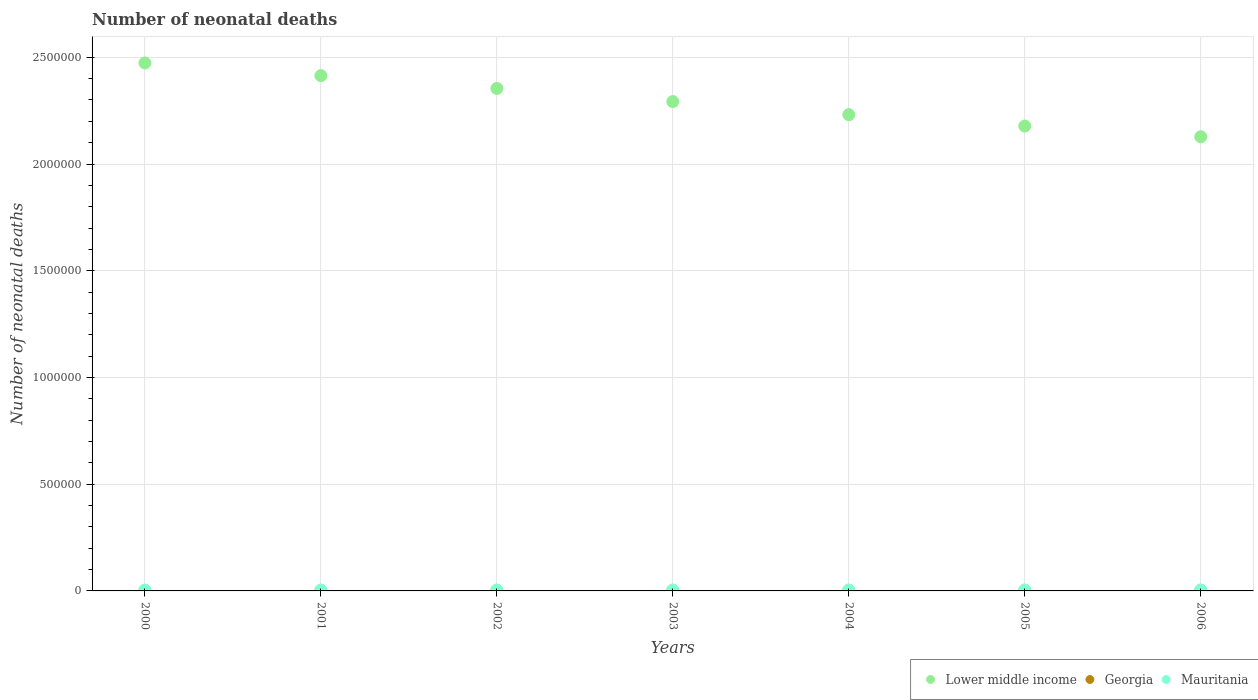Is the number of dotlines equal to the number of legend labels?
Your answer should be very brief. Yes. What is the number of neonatal deaths in in Lower middle income in 2003?
Keep it short and to the point. 2.29e+06. Across all years, what is the maximum number of neonatal deaths in in Mauritania?
Offer a very short reply. 4834. Across all years, what is the minimum number of neonatal deaths in in Lower middle income?
Provide a succinct answer. 2.13e+06. In which year was the number of neonatal deaths in in Lower middle income maximum?
Keep it short and to the point. 2000. In which year was the number of neonatal deaths in in Georgia minimum?
Offer a very short reply. 2006. What is the total number of neonatal deaths in in Mauritania in the graph?
Make the answer very short. 3.22e+04. What is the difference between the number of neonatal deaths in in Georgia in 2003 and that in 2006?
Your answer should be compact. 116. What is the difference between the number of neonatal deaths in in Georgia in 2006 and the number of neonatal deaths in in Mauritania in 2000?
Your answer should be compact. -3532. What is the average number of neonatal deaths in in Lower middle income per year?
Provide a succinct answer. 2.30e+06. In the year 2006, what is the difference between the number of neonatal deaths in in Mauritania and number of neonatal deaths in in Lower middle income?
Your answer should be compact. -2.12e+06. What is the ratio of the number of neonatal deaths in in Georgia in 2001 to that in 2005?
Your answer should be compact. 1.18. Is the difference between the number of neonatal deaths in in Mauritania in 2001 and 2002 greater than the difference between the number of neonatal deaths in in Lower middle income in 2001 and 2002?
Your response must be concise. No. What is the difference between the highest and the second highest number of neonatal deaths in in Lower middle income?
Offer a very short reply. 5.94e+04. What is the difference between the highest and the lowest number of neonatal deaths in in Georgia?
Provide a succinct answer. 260. In how many years, is the number of neonatal deaths in in Lower middle income greater than the average number of neonatal deaths in in Lower middle income taken over all years?
Offer a terse response. 3. Is the sum of the number of neonatal deaths in in Lower middle income in 2004 and 2005 greater than the maximum number of neonatal deaths in in Mauritania across all years?
Give a very brief answer. Yes. Is the number of neonatal deaths in in Mauritania strictly greater than the number of neonatal deaths in in Georgia over the years?
Your response must be concise. Yes. What is the difference between two consecutive major ticks on the Y-axis?
Make the answer very short. 5.00e+05. Are the values on the major ticks of Y-axis written in scientific E-notation?
Provide a succinct answer. No. Does the graph contain any zero values?
Keep it short and to the point. No. Where does the legend appear in the graph?
Keep it short and to the point. Bottom right. What is the title of the graph?
Make the answer very short. Number of neonatal deaths. Does "Iraq" appear as one of the legend labels in the graph?
Give a very brief answer. No. What is the label or title of the Y-axis?
Provide a succinct answer. Number of neonatal deaths. What is the Number of neonatal deaths in Lower middle income in 2000?
Make the answer very short. 2.47e+06. What is the Number of neonatal deaths of Georgia in 2000?
Offer a terse response. 1074. What is the Number of neonatal deaths in Mauritania in 2000?
Keep it short and to the point. 4346. What is the Number of neonatal deaths in Lower middle income in 2001?
Keep it short and to the point. 2.41e+06. What is the Number of neonatal deaths of Georgia in 2001?
Keep it short and to the point. 1014. What is the Number of neonatal deaths of Mauritania in 2001?
Make the answer very short. 4421. What is the Number of neonatal deaths in Lower middle income in 2002?
Provide a short and direct response. 2.35e+06. What is the Number of neonatal deaths in Georgia in 2002?
Offer a very short reply. 965. What is the Number of neonatal deaths in Mauritania in 2002?
Offer a very short reply. 4520. What is the Number of neonatal deaths of Lower middle income in 2003?
Provide a succinct answer. 2.29e+06. What is the Number of neonatal deaths in Georgia in 2003?
Provide a succinct answer. 930. What is the Number of neonatal deaths of Mauritania in 2003?
Your response must be concise. 4619. What is the Number of neonatal deaths in Lower middle income in 2004?
Provide a succinct answer. 2.23e+06. What is the Number of neonatal deaths of Georgia in 2004?
Your answer should be compact. 897. What is the Number of neonatal deaths in Mauritania in 2004?
Give a very brief answer. 4712. What is the Number of neonatal deaths in Lower middle income in 2005?
Your answer should be compact. 2.18e+06. What is the Number of neonatal deaths of Georgia in 2005?
Give a very brief answer. 856. What is the Number of neonatal deaths of Mauritania in 2005?
Your response must be concise. 4773. What is the Number of neonatal deaths of Lower middle income in 2006?
Ensure brevity in your answer.  2.13e+06. What is the Number of neonatal deaths in Georgia in 2006?
Keep it short and to the point. 814. What is the Number of neonatal deaths in Mauritania in 2006?
Make the answer very short. 4834. Across all years, what is the maximum Number of neonatal deaths of Lower middle income?
Give a very brief answer. 2.47e+06. Across all years, what is the maximum Number of neonatal deaths of Georgia?
Offer a terse response. 1074. Across all years, what is the maximum Number of neonatal deaths in Mauritania?
Provide a short and direct response. 4834. Across all years, what is the minimum Number of neonatal deaths in Lower middle income?
Offer a very short reply. 2.13e+06. Across all years, what is the minimum Number of neonatal deaths of Georgia?
Provide a short and direct response. 814. Across all years, what is the minimum Number of neonatal deaths of Mauritania?
Give a very brief answer. 4346. What is the total Number of neonatal deaths in Lower middle income in the graph?
Your answer should be compact. 1.61e+07. What is the total Number of neonatal deaths in Georgia in the graph?
Your answer should be compact. 6550. What is the total Number of neonatal deaths of Mauritania in the graph?
Your answer should be compact. 3.22e+04. What is the difference between the Number of neonatal deaths of Lower middle income in 2000 and that in 2001?
Provide a short and direct response. 5.94e+04. What is the difference between the Number of neonatal deaths of Georgia in 2000 and that in 2001?
Give a very brief answer. 60. What is the difference between the Number of neonatal deaths of Mauritania in 2000 and that in 2001?
Provide a succinct answer. -75. What is the difference between the Number of neonatal deaths in Lower middle income in 2000 and that in 2002?
Your answer should be compact. 1.19e+05. What is the difference between the Number of neonatal deaths in Georgia in 2000 and that in 2002?
Offer a terse response. 109. What is the difference between the Number of neonatal deaths of Mauritania in 2000 and that in 2002?
Offer a terse response. -174. What is the difference between the Number of neonatal deaths in Lower middle income in 2000 and that in 2003?
Offer a terse response. 1.81e+05. What is the difference between the Number of neonatal deaths in Georgia in 2000 and that in 2003?
Your answer should be compact. 144. What is the difference between the Number of neonatal deaths in Mauritania in 2000 and that in 2003?
Offer a terse response. -273. What is the difference between the Number of neonatal deaths in Lower middle income in 2000 and that in 2004?
Provide a short and direct response. 2.42e+05. What is the difference between the Number of neonatal deaths of Georgia in 2000 and that in 2004?
Make the answer very short. 177. What is the difference between the Number of neonatal deaths in Mauritania in 2000 and that in 2004?
Offer a terse response. -366. What is the difference between the Number of neonatal deaths of Lower middle income in 2000 and that in 2005?
Give a very brief answer. 2.96e+05. What is the difference between the Number of neonatal deaths in Georgia in 2000 and that in 2005?
Your answer should be very brief. 218. What is the difference between the Number of neonatal deaths in Mauritania in 2000 and that in 2005?
Keep it short and to the point. -427. What is the difference between the Number of neonatal deaths in Lower middle income in 2000 and that in 2006?
Offer a very short reply. 3.46e+05. What is the difference between the Number of neonatal deaths of Georgia in 2000 and that in 2006?
Ensure brevity in your answer.  260. What is the difference between the Number of neonatal deaths in Mauritania in 2000 and that in 2006?
Provide a succinct answer. -488. What is the difference between the Number of neonatal deaths in Lower middle income in 2001 and that in 2002?
Offer a terse response. 6.00e+04. What is the difference between the Number of neonatal deaths in Mauritania in 2001 and that in 2002?
Offer a very short reply. -99. What is the difference between the Number of neonatal deaths in Lower middle income in 2001 and that in 2003?
Provide a short and direct response. 1.22e+05. What is the difference between the Number of neonatal deaths in Mauritania in 2001 and that in 2003?
Ensure brevity in your answer.  -198. What is the difference between the Number of neonatal deaths of Lower middle income in 2001 and that in 2004?
Give a very brief answer. 1.83e+05. What is the difference between the Number of neonatal deaths of Georgia in 2001 and that in 2004?
Make the answer very short. 117. What is the difference between the Number of neonatal deaths of Mauritania in 2001 and that in 2004?
Your answer should be very brief. -291. What is the difference between the Number of neonatal deaths in Lower middle income in 2001 and that in 2005?
Your response must be concise. 2.36e+05. What is the difference between the Number of neonatal deaths in Georgia in 2001 and that in 2005?
Your answer should be very brief. 158. What is the difference between the Number of neonatal deaths of Mauritania in 2001 and that in 2005?
Your response must be concise. -352. What is the difference between the Number of neonatal deaths in Lower middle income in 2001 and that in 2006?
Ensure brevity in your answer.  2.86e+05. What is the difference between the Number of neonatal deaths in Mauritania in 2001 and that in 2006?
Your answer should be very brief. -413. What is the difference between the Number of neonatal deaths of Lower middle income in 2002 and that in 2003?
Provide a succinct answer. 6.15e+04. What is the difference between the Number of neonatal deaths in Georgia in 2002 and that in 2003?
Your answer should be very brief. 35. What is the difference between the Number of neonatal deaths of Mauritania in 2002 and that in 2003?
Your answer should be compact. -99. What is the difference between the Number of neonatal deaths of Lower middle income in 2002 and that in 2004?
Offer a terse response. 1.23e+05. What is the difference between the Number of neonatal deaths in Georgia in 2002 and that in 2004?
Ensure brevity in your answer.  68. What is the difference between the Number of neonatal deaths of Mauritania in 2002 and that in 2004?
Your answer should be very brief. -192. What is the difference between the Number of neonatal deaths of Lower middle income in 2002 and that in 2005?
Offer a terse response. 1.76e+05. What is the difference between the Number of neonatal deaths in Georgia in 2002 and that in 2005?
Ensure brevity in your answer.  109. What is the difference between the Number of neonatal deaths of Mauritania in 2002 and that in 2005?
Provide a short and direct response. -253. What is the difference between the Number of neonatal deaths of Lower middle income in 2002 and that in 2006?
Make the answer very short. 2.26e+05. What is the difference between the Number of neonatal deaths in Georgia in 2002 and that in 2006?
Offer a very short reply. 151. What is the difference between the Number of neonatal deaths in Mauritania in 2002 and that in 2006?
Make the answer very short. -314. What is the difference between the Number of neonatal deaths in Lower middle income in 2003 and that in 2004?
Keep it short and to the point. 6.13e+04. What is the difference between the Number of neonatal deaths in Mauritania in 2003 and that in 2004?
Your answer should be compact. -93. What is the difference between the Number of neonatal deaths in Lower middle income in 2003 and that in 2005?
Offer a terse response. 1.15e+05. What is the difference between the Number of neonatal deaths of Georgia in 2003 and that in 2005?
Your answer should be very brief. 74. What is the difference between the Number of neonatal deaths of Mauritania in 2003 and that in 2005?
Provide a short and direct response. -154. What is the difference between the Number of neonatal deaths of Lower middle income in 2003 and that in 2006?
Your answer should be compact. 1.65e+05. What is the difference between the Number of neonatal deaths of Georgia in 2003 and that in 2006?
Make the answer very short. 116. What is the difference between the Number of neonatal deaths in Mauritania in 2003 and that in 2006?
Your response must be concise. -215. What is the difference between the Number of neonatal deaths of Lower middle income in 2004 and that in 2005?
Your answer should be very brief. 5.34e+04. What is the difference between the Number of neonatal deaths in Mauritania in 2004 and that in 2005?
Your answer should be compact. -61. What is the difference between the Number of neonatal deaths in Lower middle income in 2004 and that in 2006?
Your answer should be compact. 1.04e+05. What is the difference between the Number of neonatal deaths in Georgia in 2004 and that in 2006?
Give a very brief answer. 83. What is the difference between the Number of neonatal deaths of Mauritania in 2004 and that in 2006?
Offer a terse response. -122. What is the difference between the Number of neonatal deaths of Lower middle income in 2005 and that in 2006?
Ensure brevity in your answer.  5.02e+04. What is the difference between the Number of neonatal deaths of Mauritania in 2005 and that in 2006?
Ensure brevity in your answer.  -61. What is the difference between the Number of neonatal deaths in Lower middle income in 2000 and the Number of neonatal deaths in Georgia in 2001?
Offer a very short reply. 2.47e+06. What is the difference between the Number of neonatal deaths in Lower middle income in 2000 and the Number of neonatal deaths in Mauritania in 2001?
Your answer should be compact. 2.47e+06. What is the difference between the Number of neonatal deaths in Georgia in 2000 and the Number of neonatal deaths in Mauritania in 2001?
Make the answer very short. -3347. What is the difference between the Number of neonatal deaths in Lower middle income in 2000 and the Number of neonatal deaths in Georgia in 2002?
Your answer should be compact. 2.47e+06. What is the difference between the Number of neonatal deaths of Lower middle income in 2000 and the Number of neonatal deaths of Mauritania in 2002?
Give a very brief answer. 2.47e+06. What is the difference between the Number of neonatal deaths in Georgia in 2000 and the Number of neonatal deaths in Mauritania in 2002?
Keep it short and to the point. -3446. What is the difference between the Number of neonatal deaths of Lower middle income in 2000 and the Number of neonatal deaths of Georgia in 2003?
Your answer should be compact. 2.47e+06. What is the difference between the Number of neonatal deaths of Lower middle income in 2000 and the Number of neonatal deaths of Mauritania in 2003?
Ensure brevity in your answer.  2.47e+06. What is the difference between the Number of neonatal deaths in Georgia in 2000 and the Number of neonatal deaths in Mauritania in 2003?
Your response must be concise. -3545. What is the difference between the Number of neonatal deaths of Lower middle income in 2000 and the Number of neonatal deaths of Georgia in 2004?
Your answer should be compact. 2.47e+06. What is the difference between the Number of neonatal deaths in Lower middle income in 2000 and the Number of neonatal deaths in Mauritania in 2004?
Your answer should be compact. 2.47e+06. What is the difference between the Number of neonatal deaths of Georgia in 2000 and the Number of neonatal deaths of Mauritania in 2004?
Your answer should be compact. -3638. What is the difference between the Number of neonatal deaths in Lower middle income in 2000 and the Number of neonatal deaths in Georgia in 2005?
Ensure brevity in your answer.  2.47e+06. What is the difference between the Number of neonatal deaths of Lower middle income in 2000 and the Number of neonatal deaths of Mauritania in 2005?
Your answer should be very brief. 2.47e+06. What is the difference between the Number of neonatal deaths of Georgia in 2000 and the Number of neonatal deaths of Mauritania in 2005?
Ensure brevity in your answer.  -3699. What is the difference between the Number of neonatal deaths in Lower middle income in 2000 and the Number of neonatal deaths in Georgia in 2006?
Your answer should be compact. 2.47e+06. What is the difference between the Number of neonatal deaths in Lower middle income in 2000 and the Number of neonatal deaths in Mauritania in 2006?
Your answer should be compact. 2.47e+06. What is the difference between the Number of neonatal deaths in Georgia in 2000 and the Number of neonatal deaths in Mauritania in 2006?
Your response must be concise. -3760. What is the difference between the Number of neonatal deaths of Lower middle income in 2001 and the Number of neonatal deaths of Georgia in 2002?
Your answer should be compact. 2.41e+06. What is the difference between the Number of neonatal deaths in Lower middle income in 2001 and the Number of neonatal deaths in Mauritania in 2002?
Your response must be concise. 2.41e+06. What is the difference between the Number of neonatal deaths of Georgia in 2001 and the Number of neonatal deaths of Mauritania in 2002?
Your answer should be compact. -3506. What is the difference between the Number of neonatal deaths in Lower middle income in 2001 and the Number of neonatal deaths in Georgia in 2003?
Offer a terse response. 2.41e+06. What is the difference between the Number of neonatal deaths in Lower middle income in 2001 and the Number of neonatal deaths in Mauritania in 2003?
Your response must be concise. 2.41e+06. What is the difference between the Number of neonatal deaths of Georgia in 2001 and the Number of neonatal deaths of Mauritania in 2003?
Your answer should be compact. -3605. What is the difference between the Number of neonatal deaths in Lower middle income in 2001 and the Number of neonatal deaths in Georgia in 2004?
Ensure brevity in your answer.  2.41e+06. What is the difference between the Number of neonatal deaths in Lower middle income in 2001 and the Number of neonatal deaths in Mauritania in 2004?
Provide a succinct answer. 2.41e+06. What is the difference between the Number of neonatal deaths in Georgia in 2001 and the Number of neonatal deaths in Mauritania in 2004?
Your answer should be very brief. -3698. What is the difference between the Number of neonatal deaths in Lower middle income in 2001 and the Number of neonatal deaths in Georgia in 2005?
Offer a very short reply. 2.41e+06. What is the difference between the Number of neonatal deaths of Lower middle income in 2001 and the Number of neonatal deaths of Mauritania in 2005?
Your answer should be very brief. 2.41e+06. What is the difference between the Number of neonatal deaths of Georgia in 2001 and the Number of neonatal deaths of Mauritania in 2005?
Give a very brief answer. -3759. What is the difference between the Number of neonatal deaths in Lower middle income in 2001 and the Number of neonatal deaths in Georgia in 2006?
Offer a very short reply. 2.41e+06. What is the difference between the Number of neonatal deaths of Lower middle income in 2001 and the Number of neonatal deaths of Mauritania in 2006?
Give a very brief answer. 2.41e+06. What is the difference between the Number of neonatal deaths in Georgia in 2001 and the Number of neonatal deaths in Mauritania in 2006?
Your answer should be compact. -3820. What is the difference between the Number of neonatal deaths of Lower middle income in 2002 and the Number of neonatal deaths of Georgia in 2003?
Provide a short and direct response. 2.35e+06. What is the difference between the Number of neonatal deaths of Lower middle income in 2002 and the Number of neonatal deaths of Mauritania in 2003?
Make the answer very short. 2.35e+06. What is the difference between the Number of neonatal deaths of Georgia in 2002 and the Number of neonatal deaths of Mauritania in 2003?
Make the answer very short. -3654. What is the difference between the Number of neonatal deaths of Lower middle income in 2002 and the Number of neonatal deaths of Georgia in 2004?
Provide a short and direct response. 2.35e+06. What is the difference between the Number of neonatal deaths of Lower middle income in 2002 and the Number of neonatal deaths of Mauritania in 2004?
Ensure brevity in your answer.  2.35e+06. What is the difference between the Number of neonatal deaths of Georgia in 2002 and the Number of neonatal deaths of Mauritania in 2004?
Give a very brief answer. -3747. What is the difference between the Number of neonatal deaths in Lower middle income in 2002 and the Number of neonatal deaths in Georgia in 2005?
Your answer should be very brief. 2.35e+06. What is the difference between the Number of neonatal deaths of Lower middle income in 2002 and the Number of neonatal deaths of Mauritania in 2005?
Your answer should be compact. 2.35e+06. What is the difference between the Number of neonatal deaths of Georgia in 2002 and the Number of neonatal deaths of Mauritania in 2005?
Offer a terse response. -3808. What is the difference between the Number of neonatal deaths in Lower middle income in 2002 and the Number of neonatal deaths in Georgia in 2006?
Offer a terse response. 2.35e+06. What is the difference between the Number of neonatal deaths of Lower middle income in 2002 and the Number of neonatal deaths of Mauritania in 2006?
Ensure brevity in your answer.  2.35e+06. What is the difference between the Number of neonatal deaths of Georgia in 2002 and the Number of neonatal deaths of Mauritania in 2006?
Give a very brief answer. -3869. What is the difference between the Number of neonatal deaths of Lower middle income in 2003 and the Number of neonatal deaths of Georgia in 2004?
Give a very brief answer. 2.29e+06. What is the difference between the Number of neonatal deaths of Lower middle income in 2003 and the Number of neonatal deaths of Mauritania in 2004?
Provide a short and direct response. 2.29e+06. What is the difference between the Number of neonatal deaths in Georgia in 2003 and the Number of neonatal deaths in Mauritania in 2004?
Provide a succinct answer. -3782. What is the difference between the Number of neonatal deaths of Lower middle income in 2003 and the Number of neonatal deaths of Georgia in 2005?
Offer a very short reply. 2.29e+06. What is the difference between the Number of neonatal deaths of Lower middle income in 2003 and the Number of neonatal deaths of Mauritania in 2005?
Your response must be concise. 2.29e+06. What is the difference between the Number of neonatal deaths in Georgia in 2003 and the Number of neonatal deaths in Mauritania in 2005?
Provide a succinct answer. -3843. What is the difference between the Number of neonatal deaths in Lower middle income in 2003 and the Number of neonatal deaths in Georgia in 2006?
Offer a very short reply. 2.29e+06. What is the difference between the Number of neonatal deaths in Lower middle income in 2003 and the Number of neonatal deaths in Mauritania in 2006?
Make the answer very short. 2.29e+06. What is the difference between the Number of neonatal deaths of Georgia in 2003 and the Number of neonatal deaths of Mauritania in 2006?
Your response must be concise. -3904. What is the difference between the Number of neonatal deaths in Lower middle income in 2004 and the Number of neonatal deaths in Georgia in 2005?
Provide a short and direct response. 2.23e+06. What is the difference between the Number of neonatal deaths in Lower middle income in 2004 and the Number of neonatal deaths in Mauritania in 2005?
Your answer should be compact. 2.23e+06. What is the difference between the Number of neonatal deaths of Georgia in 2004 and the Number of neonatal deaths of Mauritania in 2005?
Offer a very short reply. -3876. What is the difference between the Number of neonatal deaths in Lower middle income in 2004 and the Number of neonatal deaths in Georgia in 2006?
Offer a terse response. 2.23e+06. What is the difference between the Number of neonatal deaths of Lower middle income in 2004 and the Number of neonatal deaths of Mauritania in 2006?
Your answer should be compact. 2.23e+06. What is the difference between the Number of neonatal deaths of Georgia in 2004 and the Number of neonatal deaths of Mauritania in 2006?
Offer a very short reply. -3937. What is the difference between the Number of neonatal deaths in Lower middle income in 2005 and the Number of neonatal deaths in Georgia in 2006?
Make the answer very short. 2.18e+06. What is the difference between the Number of neonatal deaths of Lower middle income in 2005 and the Number of neonatal deaths of Mauritania in 2006?
Make the answer very short. 2.17e+06. What is the difference between the Number of neonatal deaths in Georgia in 2005 and the Number of neonatal deaths in Mauritania in 2006?
Your response must be concise. -3978. What is the average Number of neonatal deaths of Lower middle income per year?
Offer a terse response. 2.30e+06. What is the average Number of neonatal deaths in Georgia per year?
Ensure brevity in your answer.  935.71. What is the average Number of neonatal deaths in Mauritania per year?
Your response must be concise. 4603.57. In the year 2000, what is the difference between the Number of neonatal deaths of Lower middle income and Number of neonatal deaths of Georgia?
Provide a short and direct response. 2.47e+06. In the year 2000, what is the difference between the Number of neonatal deaths in Lower middle income and Number of neonatal deaths in Mauritania?
Ensure brevity in your answer.  2.47e+06. In the year 2000, what is the difference between the Number of neonatal deaths of Georgia and Number of neonatal deaths of Mauritania?
Offer a very short reply. -3272. In the year 2001, what is the difference between the Number of neonatal deaths of Lower middle income and Number of neonatal deaths of Georgia?
Your response must be concise. 2.41e+06. In the year 2001, what is the difference between the Number of neonatal deaths of Lower middle income and Number of neonatal deaths of Mauritania?
Your answer should be very brief. 2.41e+06. In the year 2001, what is the difference between the Number of neonatal deaths of Georgia and Number of neonatal deaths of Mauritania?
Provide a succinct answer. -3407. In the year 2002, what is the difference between the Number of neonatal deaths of Lower middle income and Number of neonatal deaths of Georgia?
Offer a very short reply. 2.35e+06. In the year 2002, what is the difference between the Number of neonatal deaths in Lower middle income and Number of neonatal deaths in Mauritania?
Make the answer very short. 2.35e+06. In the year 2002, what is the difference between the Number of neonatal deaths of Georgia and Number of neonatal deaths of Mauritania?
Give a very brief answer. -3555. In the year 2003, what is the difference between the Number of neonatal deaths in Lower middle income and Number of neonatal deaths in Georgia?
Give a very brief answer. 2.29e+06. In the year 2003, what is the difference between the Number of neonatal deaths of Lower middle income and Number of neonatal deaths of Mauritania?
Keep it short and to the point. 2.29e+06. In the year 2003, what is the difference between the Number of neonatal deaths in Georgia and Number of neonatal deaths in Mauritania?
Keep it short and to the point. -3689. In the year 2004, what is the difference between the Number of neonatal deaths of Lower middle income and Number of neonatal deaths of Georgia?
Keep it short and to the point. 2.23e+06. In the year 2004, what is the difference between the Number of neonatal deaths in Lower middle income and Number of neonatal deaths in Mauritania?
Offer a very short reply. 2.23e+06. In the year 2004, what is the difference between the Number of neonatal deaths of Georgia and Number of neonatal deaths of Mauritania?
Provide a succinct answer. -3815. In the year 2005, what is the difference between the Number of neonatal deaths in Lower middle income and Number of neonatal deaths in Georgia?
Offer a very short reply. 2.18e+06. In the year 2005, what is the difference between the Number of neonatal deaths of Lower middle income and Number of neonatal deaths of Mauritania?
Offer a terse response. 2.17e+06. In the year 2005, what is the difference between the Number of neonatal deaths in Georgia and Number of neonatal deaths in Mauritania?
Your answer should be very brief. -3917. In the year 2006, what is the difference between the Number of neonatal deaths of Lower middle income and Number of neonatal deaths of Georgia?
Ensure brevity in your answer.  2.13e+06. In the year 2006, what is the difference between the Number of neonatal deaths in Lower middle income and Number of neonatal deaths in Mauritania?
Your response must be concise. 2.12e+06. In the year 2006, what is the difference between the Number of neonatal deaths of Georgia and Number of neonatal deaths of Mauritania?
Make the answer very short. -4020. What is the ratio of the Number of neonatal deaths in Lower middle income in 2000 to that in 2001?
Your answer should be very brief. 1.02. What is the ratio of the Number of neonatal deaths of Georgia in 2000 to that in 2001?
Your answer should be compact. 1.06. What is the ratio of the Number of neonatal deaths in Lower middle income in 2000 to that in 2002?
Offer a terse response. 1.05. What is the ratio of the Number of neonatal deaths in Georgia in 2000 to that in 2002?
Your answer should be very brief. 1.11. What is the ratio of the Number of neonatal deaths in Mauritania in 2000 to that in 2002?
Offer a very short reply. 0.96. What is the ratio of the Number of neonatal deaths of Lower middle income in 2000 to that in 2003?
Give a very brief answer. 1.08. What is the ratio of the Number of neonatal deaths in Georgia in 2000 to that in 2003?
Make the answer very short. 1.15. What is the ratio of the Number of neonatal deaths in Mauritania in 2000 to that in 2003?
Give a very brief answer. 0.94. What is the ratio of the Number of neonatal deaths of Lower middle income in 2000 to that in 2004?
Ensure brevity in your answer.  1.11. What is the ratio of the Number of neonatal deaths of Georgia in 2000 to that in 2004?
Your answer should be compact. 1.2. What is the ratio of the Number of neonatal deaths in Mauritania in 2000 to that in 2004?
Provide a short and direct response. 0.92. What is the ratio of the Number of neonatal deaths in Lower middle income in 2000 to that in 2005?
Offer a terse response. 1.14. What is the ratio of the Number of neonatal deaths of Georgia in 2000 to that in 2005?
Your response must be concise. 1.25. What is the ratio of the Number of neonatal deaths in Mauritania in 2000 to that in 2005?
Your response must be concise. 0.91. What is the ratio of the Number of neonatal deaths of Lower middle income in 2000 to that in 2006?
Give a very brief answer. 1.16. What is the ratio of the Number of neonatal deaths of Georgia in 2000 to that in 2006?
Make the answer very short. 1.32. What is the ratio of the Number of neonatal deaths of Mauritania in 2000 to that in 2006?
Ensure brevity in your answer.  0.9. What is the ratio of the Number of neonatal deaths of Lower middle income in 2001 to that in 2002?
Your response must be concise. 1.03. What is the ratio of the Number of neonatal deaths in Georgia in 2001 to that in 2002?
Give a very brief answer. 1.05. What is the ratio of the Number of neonatal deaths in Mauritania in 2001 to that in 2002?
Your answer should be compact. 0.98. What is the ratio of the Number of neonatal deaths of Lower middle income in 2001 to that in 2003?
Keep it short and to the point. 1.05. What is the ratio of the Number of neonatal deaths of Georgia in 2001 to that in 2003?
Ensure brevity in your answer.  1.09. What is the ratio of the Number of neonatal deaths of Mauritania in 2001 to that in 2003?
Your response must be concise. 0.96. What is the ratio of the Number of neonatal deaths of Lower middle income in 2001 to that in 2004?
Your answer should be compact. 1.08. What is the ratio of the Number of neonatal deaths in Georgia in 2001 to that in 2004?
Offer a terse response. 1.13. What is the ratio of the Number of neonatal deaths of Mauritania in 2001 to that in 2004?
Your response must be concise. 0.94. What is the ratio of the Number of neonatal deaths in Lower middle income in 2001 to that in 2005?
Provide a succinct answer. 1.11. What is the ratio of the Number of neonatal deaths in Georgia in 2001 to that in 2005?
Ensure brevity in your answer.  1.18. What is the ratio of the Number of neonatal deaths of Mauritania in 2001 to that in 2005?
Keep it short and to the point. 0.93. What is the ratio of the Number of neonatal deaths of Lower middle income in 2001 to that in 2006?
Your answer should be very brief. 1.13. What is the ratio of the Number of neonatal deaths of Georgia in 2001 to that in 2006?
Provide a short and direct response. 1.25. What is the ratio of the Number of neonatal deaths of Mauritania in 2001 to that in 2006?
Your response must be concise. 0.91. What is the ratio of the Number of neonatal deaths in Lower middle income in 2002 to that in 2003?
Offer a very short reply. 1.03. What is the ratio of the Number of neonatal deaths of Georgia in 2002 to that in 2003?
Your response must be concise. 1.04. What is the ratio of the Number of neonatal deaths of Mauritania in 2002 to that in 2003?
Keep it short and to the point. 0.98. What is the ratio of the Number of neonatal deaths in Lower middle income in 2002 to that in 2004?
Your response must be concise. 1.05. What is the ratio of the Number of neonatal deaths of Georgia in 2002 to that in 2004?
Keep it short and to the point. 1.08. What is the ratio of the Number of neonatal deaths in Mauritania in 2002 to that in 2004?
Your answer should be very brief. 0.96. What is the ratio of the Number of neonatal deaths in Lower middle income in 2002 to that in 2005?
Offer a terse response. 1.08. What is the ratio of the Number of neonatal deaths of Georgia in 2002 to that in 2005?
Provide a succinct answer. 1.13. What is the ratio of the Number of neonatal deaths of Mauritania in 2002 to that in 2005?
Give a very brief answer. 0.95. What is the ratio of the Number of neonatal deaths in Lower middle income in 2002 to that in 2006?
Offer a terse response. 1.11. What is the ratio of the Number of neonatal deaths in Georgia in 2002 to that in 2006?
Your response must be concise. 1.19. What is the ratio of the Number of neonatal deaths in Mauritania in 2002 to that in 2006?
Give a very brief answer. 0.94. What is the ratio of the Number of neonatal deaths in Lower middle income in 2003 to that in 2004?
Your answer should be very brief. 1.03. What is the ratio of the Number of neonatal deaths in Georgia in 2003 to that in 2004?
Your answer should be very brief. 1.04. What is the ratio of the Number of neonatal deaths of Mauritania in 2003 to that in 2004?
Offer a very short reply. 0.98. What is the ratio of the Number of neonatal deaths of Lower middle income in 2003 to that in 2005?
Keep it short and to the point. 1.05. What is the ratio of the Number of neonatal deaths in Georgia in 2003 to that in 2005?
Offer a very short reply. 1.09. What is the ratio of the Number of neonatal deaths in Lower middle income in 2003 to that in 2006?
Make the answer very short. 1.08. What is the ratio of the Number of neonatal deaths of Georgia in 2003 to that in 2006?
Your answer should be compact. 1.14. What is the ratio of the Number of neonatal deaths in Mauritania in 2003 to that in 2006?
Offer a very short reply. 0.96. What is the ratio of the Number of neonatal deaths of Lower middle income in 2004 to that in 2005?
Offer a very short reply. 1.02. What is the ratio of the Number of neonatal deaths in Georgia in 2004 to that in 2005?
Ensure brevity in your answer.  1.05. What is the ratio of the Number of neonatal deaths of Mauritania in 2004 to that in 2005?
Your answer should be compact. 0.99. What is the ratio of the Number of neonatal deaths of Lower middle income in 2004 to that in 2006?
Your answer should be compact. 1.05. What is the ratio of the Number of neonatal deaths of Georgia in 2004 to that in 2006?
Offer a terse response. 1.1. What is the ratio of the Number of neonatal deaths of Mauritania in 2004 to that in 2006?
Offer a very short reply. 0.97. What is the ratio of the Number of neonatal deaths of Lower middle income in 2005 to that in 2006?
Provide a short and direct response. 1.02. What is the ratio of the Number of neonatal deaths in Georgia in 2005 to that in 2006?
Your answer should be very brief. 1.05. What is the ratio of the Number of neonatal deaths in Mauritania in 2005 to that in 2006?
Provide a short and direct response. 0.99. What is the difference between the highest and the second highest Number of neonatal deaths in Lower middle income?
Provide a short and direct response. 5.94e+04. What is the difference between the highest and the second highest Number of neonatal deaths of Georgia?
Offer a very short reply. 60. What is the difference between the highest and the second highest Number of neonatal deaths in Mauritania?
Provide a succinct answer. 61. What is the difference between the highest and the lowest Number of neonatal deaths in Lower middle income?
Keep it short and to the point. 3.46e+05. What is the difference between the highest and the lowest Number of neonatal deaths of Georgia?
Give a very brief answer. 260. What is the difference between the highest and the lowest Number of neonatal deaths in Mauritania?
Ensure brevity in your answer.  488. 